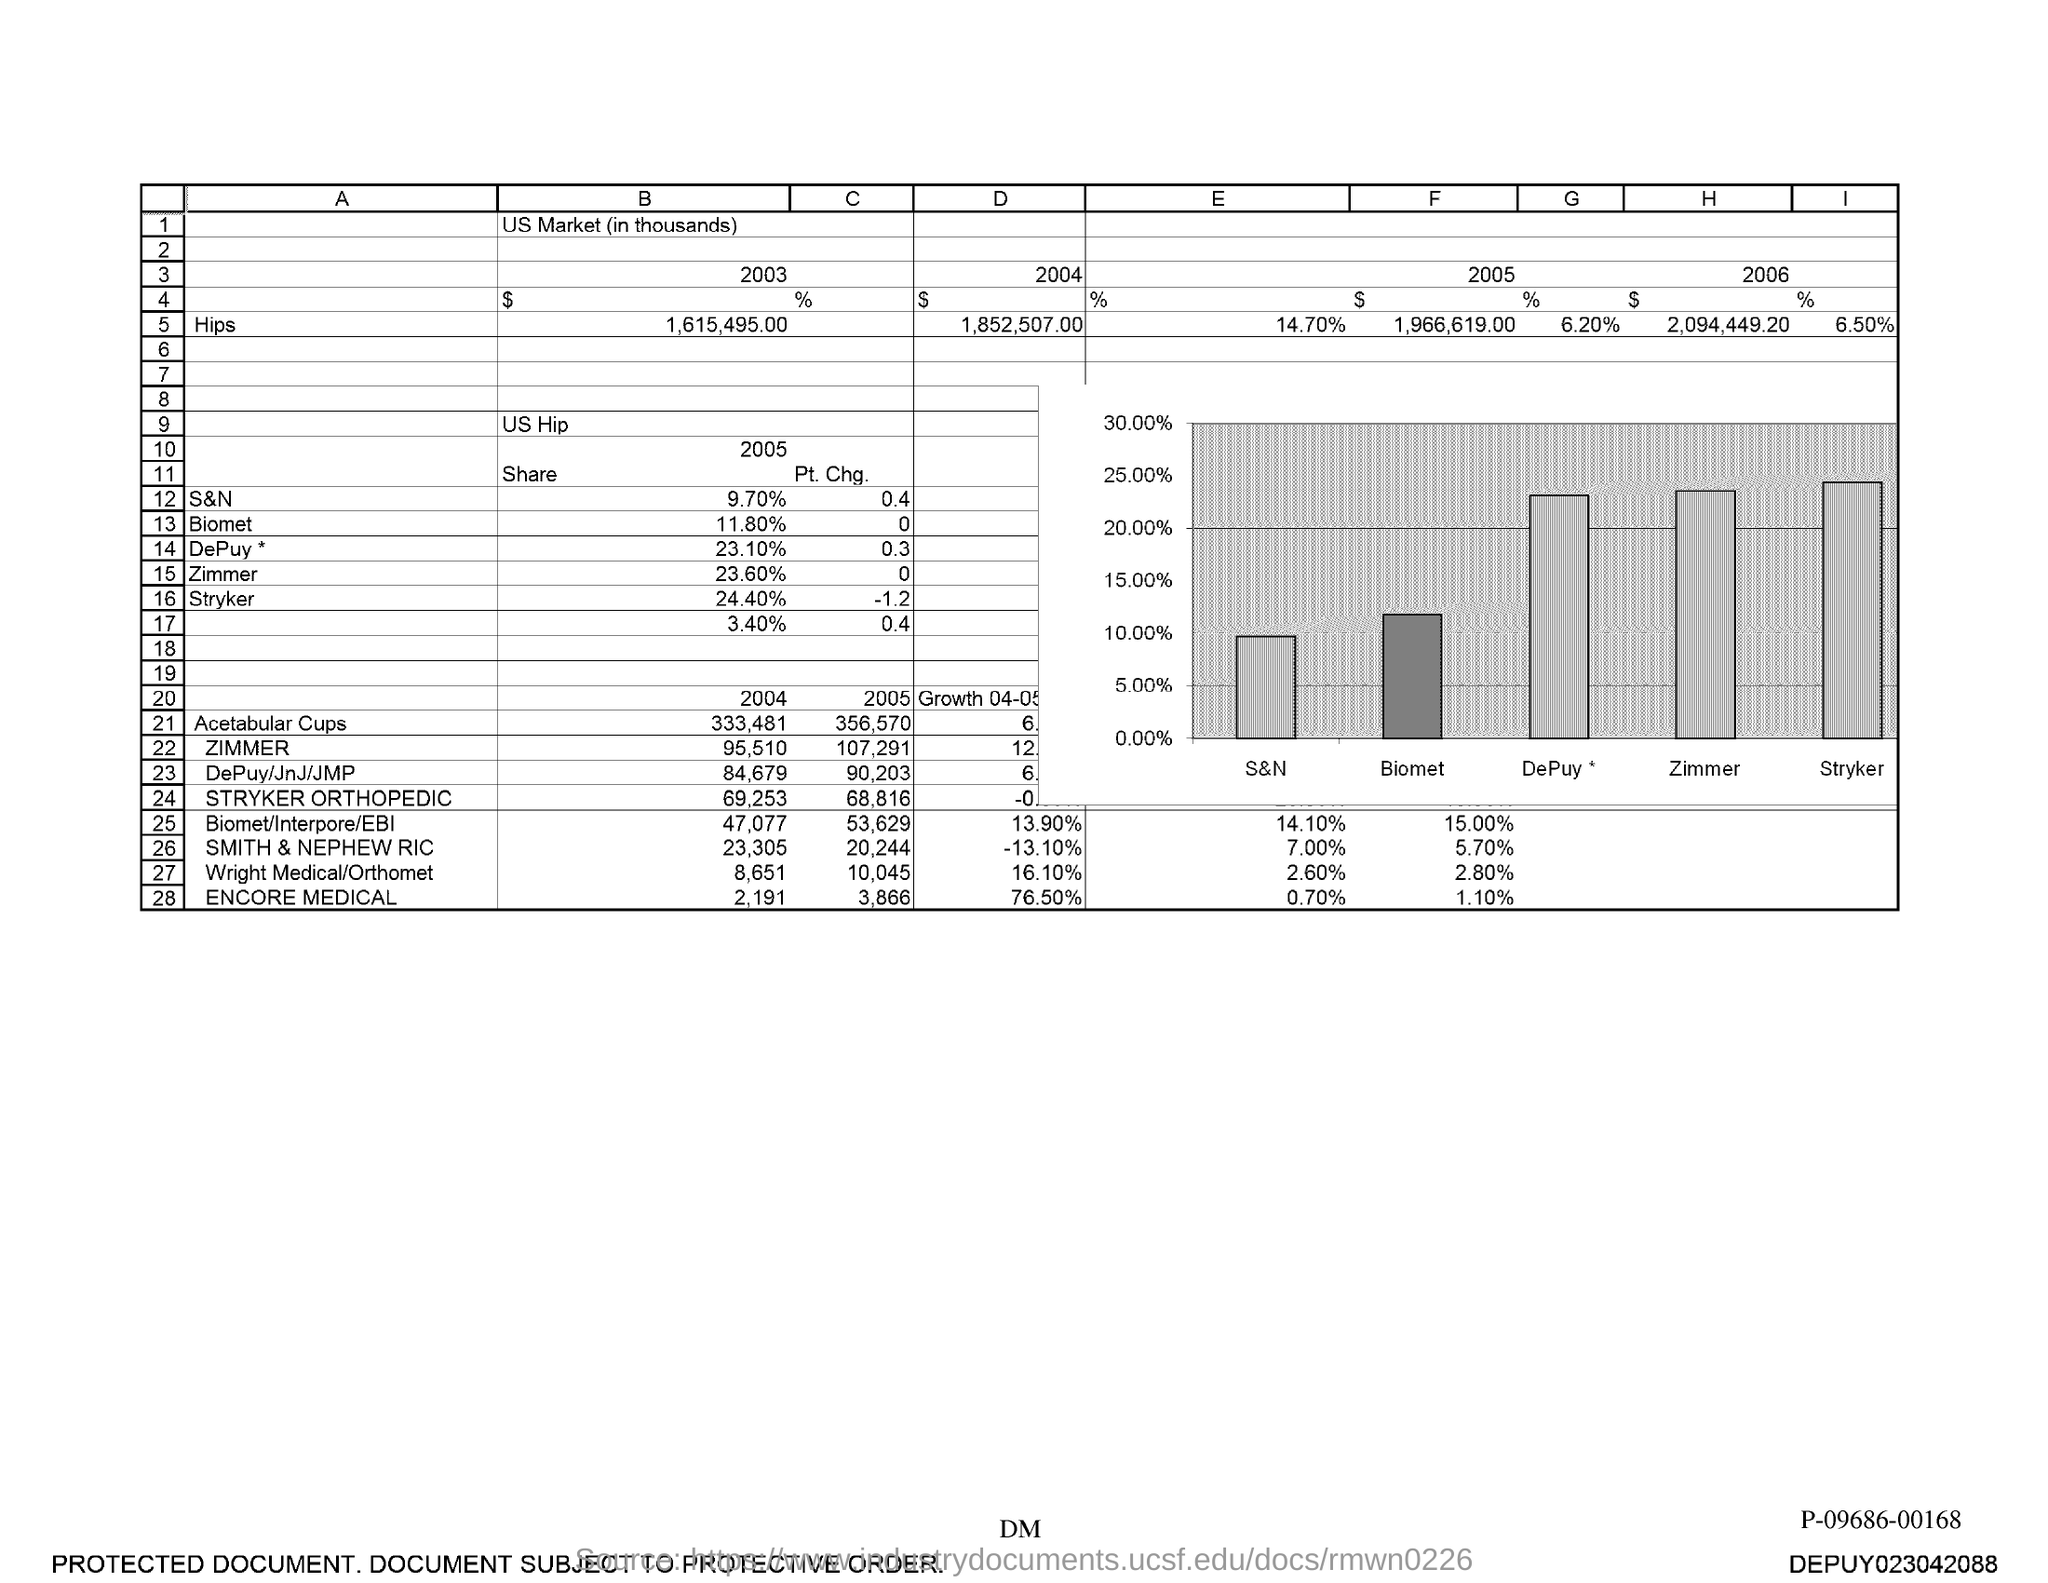Outline some significant characteristics in this image. In 2004, the value of Hips was 1,852,507. 